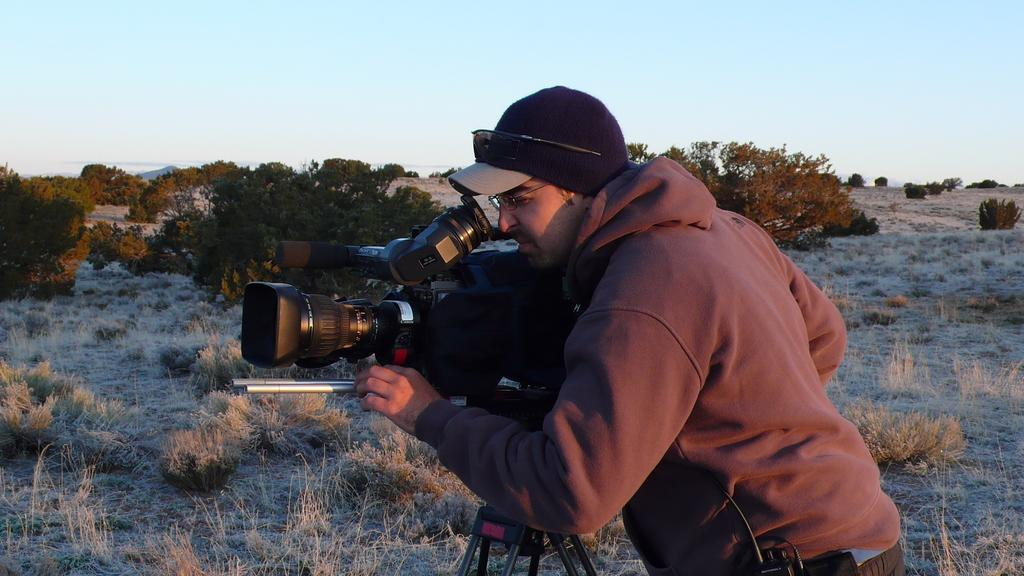What is the person in the image doing? The person is standing in the image and holding a camera. How is the camera positioned in the image? The camera is on a tripod stand. What can be seen in the background of the image? There are plants, grass, and the sky visible in the background of the image. Where is the sofa located in the image? There is no sofa present in the image. What type of son is the person in the image talking to? There is no son present in the image, and the person is not talking to anyone. 